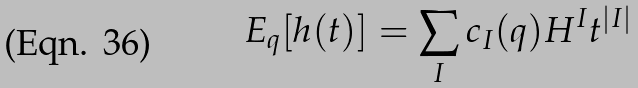Convert formula to latex. <formula><loc_0><loc_0><loc_500><loc_500>E _ { q } [ h ( t ) ] = \sum _ { I } c _ { I } ( q ) H ^ { I } t ^ { | I | }</formula> 